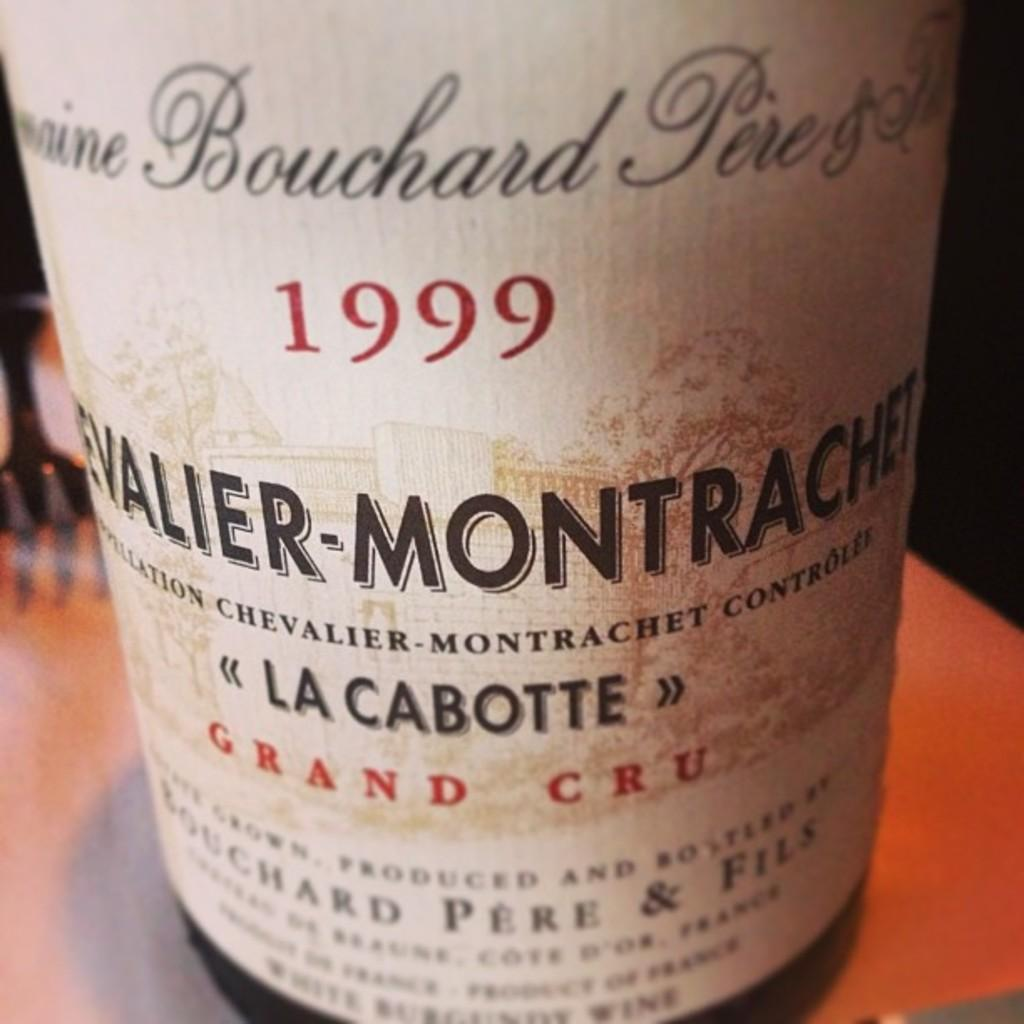What object can be seen in the picture? There is a bottle in the picture. Where is the bottle located? The bottle is on a surface. What can be found on the bottle's label? There is writing on the bottle's label. Can you describe the crow that is sitting on the rail in the image? There is no crow or rail present in the image; it only features a bottle on a surface with writing on its label. 